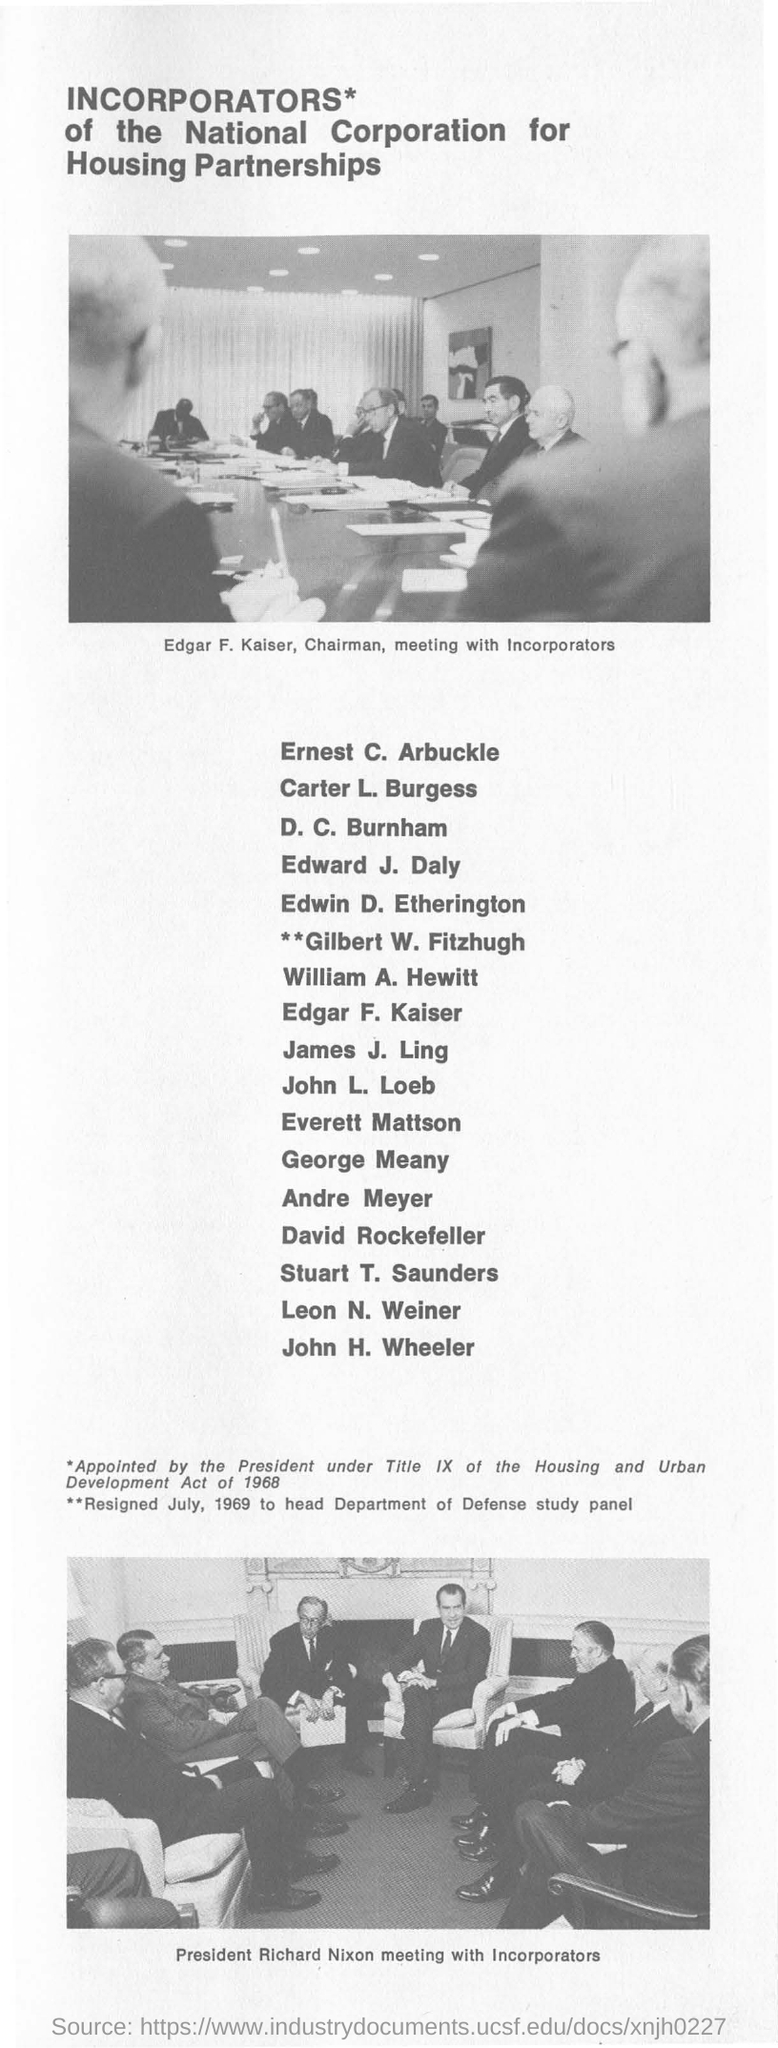Indicate a few pertinent items in this graphic. Edgar F. Kaiser is the chairman. 